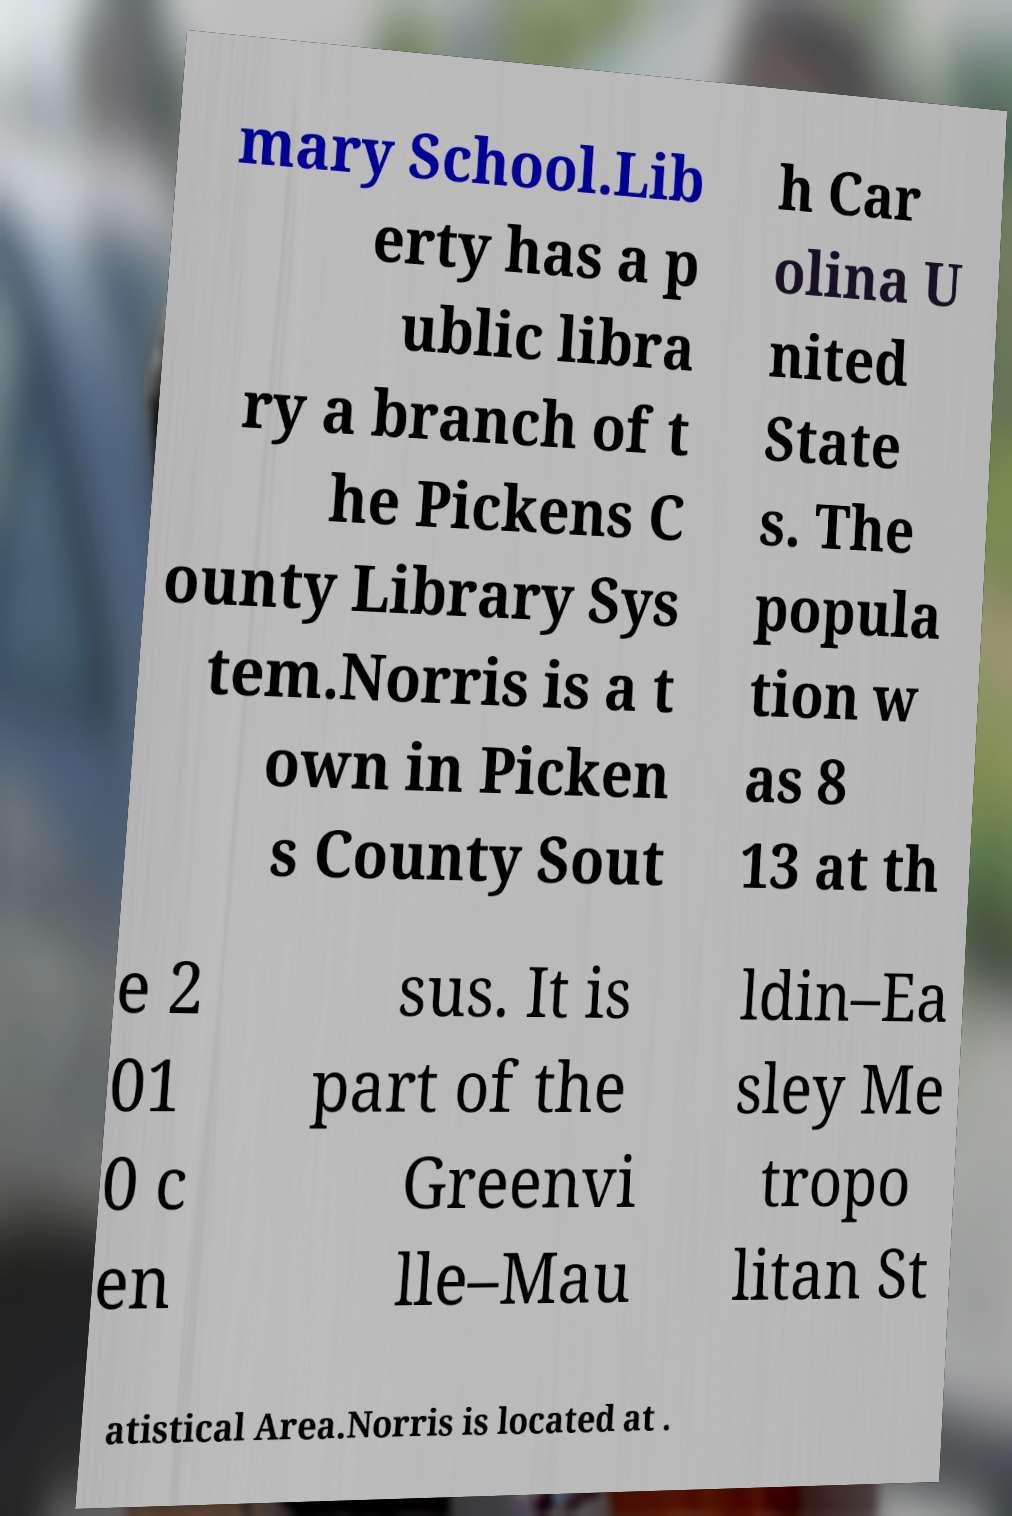Could you assist in decoding the text presented in this image and type it out clearly? mary School.Lib erty has a p ublic libra ry a branch of t he Pickens C ounty Library Sys tem.Norris is a t own in Picken s County Sout h Car olina U nited State s. The popula tion w as 8 13 at th e 2 01 0 c en sus. It is part of the Greenvi lle–Mau ldin–Ea sley Me tropo litan St atistical Area.Norris is located at . 